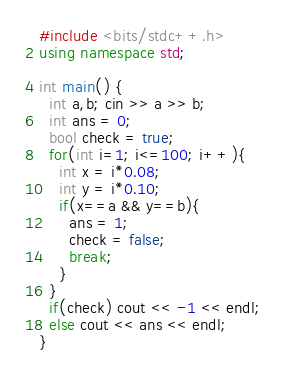Convert code to text. <code><loc_0><loc_0><loc_500><loc_500><_C++_>#include <bits/stdc++.h>
using namespace std;
 
int main() {
  int a,b; cin >> a >> b;
  int ans = 0;
  bool check = true;
  for(int i=1; i<=100; i++){
    int x = i*0.08;
  	int y = i*0.10;
    if(x==a && y==b){
      ans = 1;
      check = false;
      break;
    }
  }
  if(check) cout << -1 << endl;
  else cout << ans << endl;
}</code> 